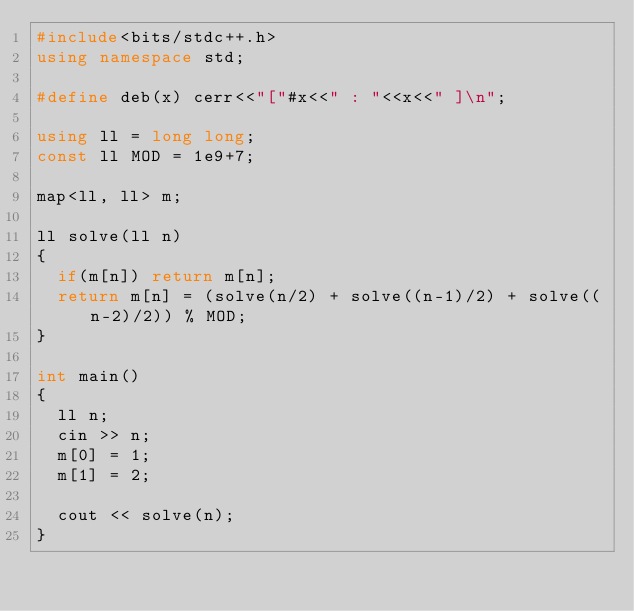<code> <loc_0><loc_0><loc_500><loc_500><_C++_>#include<bits/stdc++.h>
using namespace std;

#define deb(x) cerr<<"["#x<<" : "<<x<<" ]\n";

using ll = long long;
const ll MOD = 1e9+7;

map<ll, ll> m;

ll solve(ll n)
{
	if(m[n]) return m[n];
	return m[n] = (solve(n/2) + solve((n-1)/2) + solve((n-2)/2)) % MOD;
}

int main()
{
	ll n;
	cin >> n;
	m[0] = 1;
	m[1] = 2;
	
	cout << solve(n);
}
</code> 